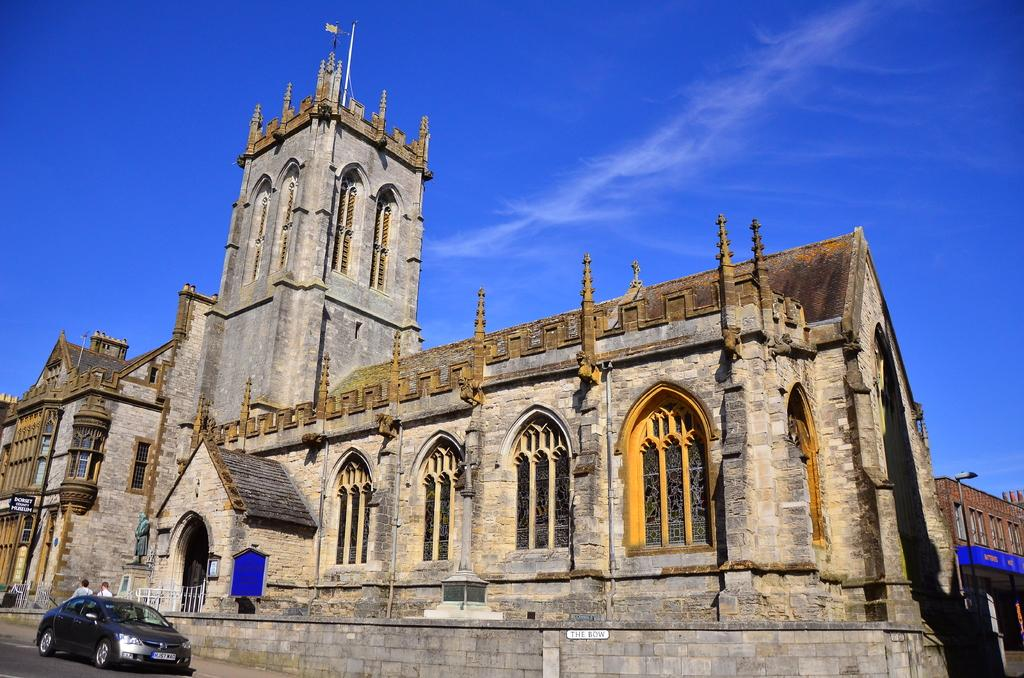What type of structures can be seen in the image? There are buildings in the image. What else can be seen in the image besides buildings? There are poles and hoardings visible in the image. What is visible in the sky in the image? There are clouds visible in the image. Where is the car located in the image? The car is in the bottom left corner of the image. Are there any people present in the image? Yes, there are people in the image. Reasoning: To produce the conversation, we first identify the main subjects and objects in the image based on the provided facts. We then formulate questions that focus on the location and characteristics of these subjects and objects, ensuring that each question can be answered definitively with the information given. We avoid yes/no questions and ensure that the language is simple and clear. Absurd Question/Answer: What type of finger can be seen on the calculator in the image? There is no finger or calculator present in the image. How do the people in the image say good-bye to each other? There is no indication of people saying good-bye in the image. What type of finger can be seen on the calculator in the image? There is no finger or calculator present in the image. How do the people in the image say good-bye to each other? There is no indication of people saying good-bye in the image. 